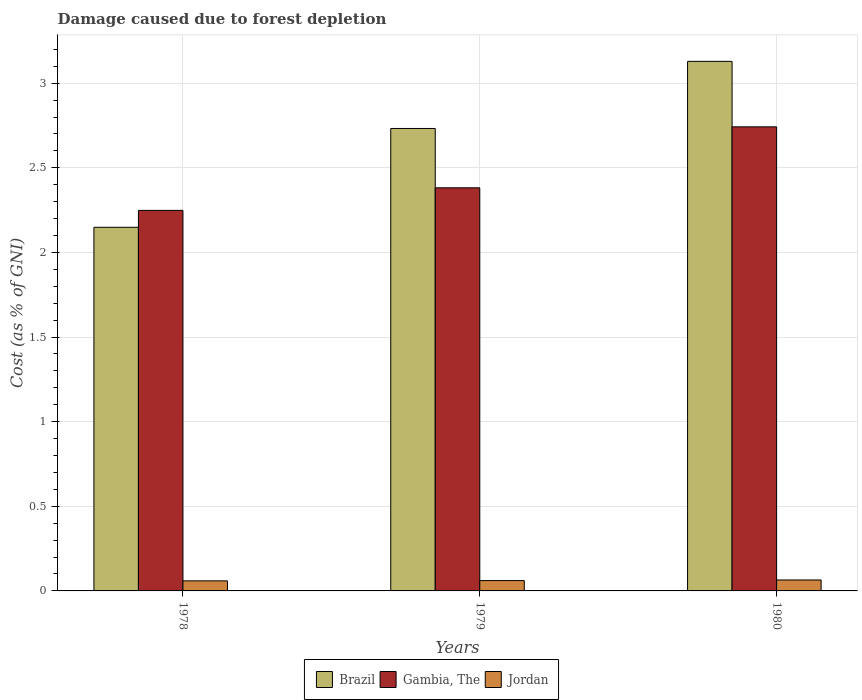How many different coloured bars are there?
Provide a succinct answer. 3. Are the number of bars per tick equal to the number of legend labels?
Your response must be concise. Yes. Are the number of bars on each tick of the X-axis equal?
Offer a very short reply. Yes. How many bars are there on the 1st tick from the left?
Your answer should be very brief. 3. What is the label of the 3rd group of bars from the left?
Your answer should be compact. 1980. What is the cost of damage caused due to forest depletion in Brazil in 1980?
Offer a terse response. 3.13. Across all years, what is the maximum cost of damage caused due to forest depletion in Jordan?
Give a very brief answer. 0.06. Across all years, what is the minimum cost of damage caused due to forest depletion in Brazil?
Offer a terse response. 2.15. In which year was the cost of damage caused due to forest depletion in Brazil minimum?
Your answer should be very brief. 1978. What is the total cost of damage caused due to forest depletion in Jordan in the graph?
Give a very brief answer. 0.19. What is the difference between the cost of damage caused due to forest depletion in Brazil in 1978 and that in 1980?
Your answer should be very brief. -0.98. What is the difference between the cost of damage caused due to forest depletion in Brazil in 1979 and the cost of damage caused due to forest depletion in Gambia, The in 1980?
Offer a very short reply. -0.01. What is the average cost of damage caused due to forest depletion in Jordan per year?
Your answer should be compact. 0.06. In the year 1979, what is the difference between the cost of damage caused due to forest depletion in Brazil and cost of damage caused due to forest depletion in Jordan?
Keep it short and to the point. 2.67. In how many years, is the cost of damage caused due to forest depletion in Brazil greater than 1.2 %?
Provide a succinct answer. 3. What is the ratio of the cost of damage caused due to forest depletion in Brazil in 1978 to that in 1979?
Offer a very short reply. 0.79. Is the difference between the cost of damage caused due to forest depletion in Brazil in 1978 and 1980 greater than the difference between the cost of damage caused due to forest depletion in Jordan in 1978 and 1980?
Provide a succinct answer. No. What is the difference between the highest and the second highest cost of damage caused due to forest depletion in Brazil?
Your response must be concise. 0.4. What is the difference between the highest and the lowest cost of damage caused due to forest depletion in Gambia, The?
Your response must be concise. 0.49. In how many years, is the cost of damage caused due to forest depletion in Brazil greater than the average cost of damage caused due to forest depletion in Brazil taken over all years?
Your answer should be compact. 2. Is the sum of the cost of damage caused due to forest depletion in Jordan in 1979 and 1980 greater than the maximum cost of damage caused due to forest depletion in Brazil across all years?
Keep it short and to the point. No. What does the 2nd bar from the left in 1979 represents?
Offer a very short reply. Gambia, The. What does the 1st bar from the right in 1980 represents?
Your answer should be compact. Jordan. How many bars are there?
Provide a succinct answer. 9. Are the values on the major ticks of Y-axis written in scientific E-notation?
Provide a short and direct response. No. Does the graph contain any zero values?
Ensure brevity in your answer.  No. Where does the legend appear in the graph?
Offer a terse response. Bottom center. How many legend labels are there?
Give a very brief answer. 3. How are the legend labels stacked?
Your answer should be compact. Horizontal. What is the title of the graph?
Your answer should be very brief. Damage caused due to forest depletion. What is the label or title of the Y-axis?
Give a very brief answer. Cost (as % of GNI). What is the Cost (as % of GNI) of Brazil in 1978?
Provide a short and direct response. 2.15. What is the Cost (as % of GNI) in Gambia, The in 1978?
Your answer should be very brief. 2.25. What is the Cost (as % of GNI) of Jordan in 1978?
Provide a succinct answer. 0.06. What is the Cost (as % of GNI) in Brazil in 1979?
Provide a short and direct response. 2.73. What is the Cost (as % of GNI) of Gambia, The in 1979?
Offer a very short reply. 2.38. What is the Cost (as % of GNI) of Jordan in 1979?
Offer a very short reply. 0.06. What is the Cost (as % of GNI) of Brazil in 1980?
Your answer should be compact. 3.13. What is the Cost (as % of GNI) of Gambia, The in 1980?
Your answer should be compact. 2.74. What is the Cost (as % of GNI) in Jordan in 1980?
Your response must be concise. 0.06. Across all years, what is the maximum Cost (as % of GNI) in Brazil?
Your response must be concise. 3.13. Across all years, what is the maximum Cost (as % of GNI) of Gambia, The?
Give a very brief answer. 2.74. Across all years, what is the maximum Cost (as % of GNI) of Jordan?
Ensure brevity in your answer.  0.06. Across all years, what is the minimum Cost (as % of GNI) of Brazil?
Provide a short and direct response. 2.15. Across all years, what is the minimum Cost (as % of GNI) of Gambia, The?
Keep it short and to the point. 2.25. Across all years, what is the minimum Cost (as % of GNI) in Jordan?
Your answer should be compact. 0.06. What is the total Cost (as % of GNI) in Brazil in the graph?
Keep it short and to the point. 8.01. What is the total Cost (as % of GNI) in Gambia, The in the graph?
Keep it short and to the point. 7.37. What is the total Cost (as % of GNI) in Jordan in the graph?
Give a very brief answer. 0.19. What is the difference between the Cost (as % of GNI) of Brazil in 1978 and that in 1979?
Provide a short and direct response. -0.58. What is the difference between the Cost (as % of GNI) of Gambia, The in 1978 and that in 1979?
Provide a short and direct response. -0.13. What is the difference between the Cost (as % of GNI) in Jordan in 1978 and that in 1979?
Offer a terse response. -0. What is the difference between the Cost (as % of GNI) in Brazil in 1978 and that in 1980?
Offer a terse response. -0.98. What is the difference between the Cost (as % of GNI) in Gambia, The in 1978 and that in 1980?
Make the answer very short. -0.49. What is the difference between the Cost (as % of GNI) of Jordan in 1978 and that in 1980?
Your answer should be compact. -0.01. What is the difference between the Cost (as % of GNI) of Brazil in 1979 and that in 1980?
Your response must be concise. -0.4. What is the difference between the Cost (as % of GNI) in Gambia, The in 1979 and that in 1980?
Provide a succinct answer. -0.36. What is the difference between the Cost (as % of GNI) in Jordan in 1979 and that in 1980?
Your response must be concise. -0. What is the difference between the Cost (as % of GNI) of Brazil in 1978 and the Cost (as % of GNI) of Gambia, The in 1979?
Provide a succinct answer. -0.23. What is the difference between the Cost (as % of GNI) of Brazil in 1978 and the Cost (as % of GNI) of Jordan in 1979?
Provide a succinct answer. 2.09. What is the difference between the Cost (as % of GNI) of Gambia, The in 1978 and the Cost (as % of GNI) of Jordan in 1979?
Your answer should be compact. 2.19. What is the difference between the Cost (as % of GNI) in Brazil in 1978 and the Cost (as % of GNI) in Gambia, The in 1980?
Give a very brief answer. -0.59. What is the difference between the Cost (as % of GNI) in Brazil in 1978 and the Cost (as % of GNI) in Jordan in 1980?
Give a very brief answer. 2.08. What is the difference between the Cost (as % of GNI) in Gambia, The in 1978 and the Cost (as % of GNI) in Jordan in 1980?
Your answer should be very brief. 2.18. What is the difference between the Cost (as % of GNI) of Brazil in 1979 and the Cost (as % of GNI) of Gambia, The in 1980?
Ensure brevity in your answer.  -0.01. What is the difference between the Cost (as % of GNI) of Brazil in 1979 and the Cost (as % of GNI) of Jordan in 1980?
Offer a very short reply. 2.67. What is the difference between the Cost (as % of GNI) of Gambia, The in 1979 and the Cost (as % of GNI) of Jordan in 1980?
Make the answer very short. 2.32. What is the average Cost (as % of GNI) in Brazil per year?
Provide a short and direct response. 2.67. What is the average Cost (as % of GNI) in Gambia, The per year?
Offer a very short reply. 2.46. What is the average Cost (as % of GNI) in Jordan per year?
Your response must be concise. 0.06. In the year 1978, what is the difference between the Cost (as % of GNI) in Brazil and Cost (as % of GNI) in Gambia, The?
Provide a succinct answer. -0.1. In the year 1978, what is the difference between the Cost (as % of GNI) of Brazil and Cost (as % of GNI) of Jordan?
Your response must be concise. 2.09. In the year 1978, what is the difference between the Cost (as % of GNI) in Gambia, The and Cost (as % of GNI) in Jordan?
Ensure brevity in your answer.  2.19. In the year 1979, what is the difference between the Cost (as % of GNI) of Brazil and Cost (as % of GNI) of Gambia, The?
Your answer should be compact. 0.35. In the year 1979, what is the difference between the Cost (as % of GNI) in Brazil and Cost (as % of GNI) in Jordan?
Your response must be concise. 2.67. In the year 1979, what is the difference between the Cost (as % of GNI) in Gambia, The and Cost (as % of GNI) in Jordan?
Make the answer very short. 2.32. In the year 1980, what is the difference between the Cost (as % of GNI) in Brazil and Cost (as % of GNI) in Gambia, The?
Keep it short and to the point. 0.39. In the year 1980, what is the difference between the Cost (as % of GNI) of Brazil and Cost (as % of GNI) of Jordan?
Your response must be concise. 3.06. In the year 1980, what is the difference between the Cost (as % of GNI) in Gambia, The and Cost (as % of GNI) in Jordan?
Offer a terse response. 2.68. What is the ratio of the Cost (as % of GNI) in Brazil in 1978 to that in 1979?
Offer a terse response. 0.79. What is the ratio of the Cost (as % of GNI) of Gambia, The in 1978 to that in 1979?
Provide a short and direct response. 0.94. What is the ratio of the Cost (as % of GNI) of Jordan in 1978 to that in 1979?
Provide a short and direct response. 0.97. What is the ratio of the Cost (as % of GNI) in Brazil in 1978 to that in 1980?
Ensure brevity in your answer.  0.69. What is the ratio of the Cost (as % of GNI) in Gambia, The in 1978 to that in 1980?
Provide a succinct answer. 0.82. What is the ratio of the Cost (as % of GNI) in Jordan in 1978 to that in 1980?
Your answer should be very brief. 0.92. What is the ratio of the Cost (as % of GNI) of Brazil in 1979 to that in 1980?
Your response must be concise. 0.87. What is the ratio of the Cost (as % of GNI) in Gambia, The in 1979 to that in 1980?
Ensure brevity in your answer.  0.87. What is the ratio of the Cost (as % of GNI) of Jordan in 1979 to that in 1980?
Ensure brevity in your answer.  0.94. What is the difference between the highest and the second highest Cost (as % of GNI) of Brazil?
Your response must be concise. 0.4. What is the difference between the highest and the second highest Cost (as % of GNI) in Gambia, The?
Give a very brief answer. 0.36. What is the difference between the highest and the second highest Cost (as % of GNI) in Jordan?
Provide a succinct answer. 0. What is the difference between the highest and the lowest Cost (as % of GNI) in Brazil?
Provide a succinct answer. 0.98. What is the difference between the highest and the lowest Cost (as % of GNI) in Gambia, The?
Provide a short and direct response. 0.49. What is the difference between the highest and the lowest Cost (as % of GNI) of Jordan?
Make the answer very short. 0.01. 